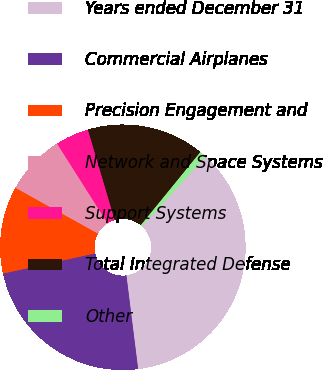<chart> <loc_0><loc_0><loc_500><loc_500><pie_chart><fcel>Years ended December 31<fcel>Commercial Airplanes<fcel>Precision Engagement and<fcel>Network and Space Systems<fcel>Support Systems<fcel>Total Integrated Defense<fcel>Other<nl><fcel>36.27%<fcel>23.55%<fcel>11.49%<fcel>7.95%<fcel>4.41%<fcel>15.47%<fcel>0.87%<nl></chart> 